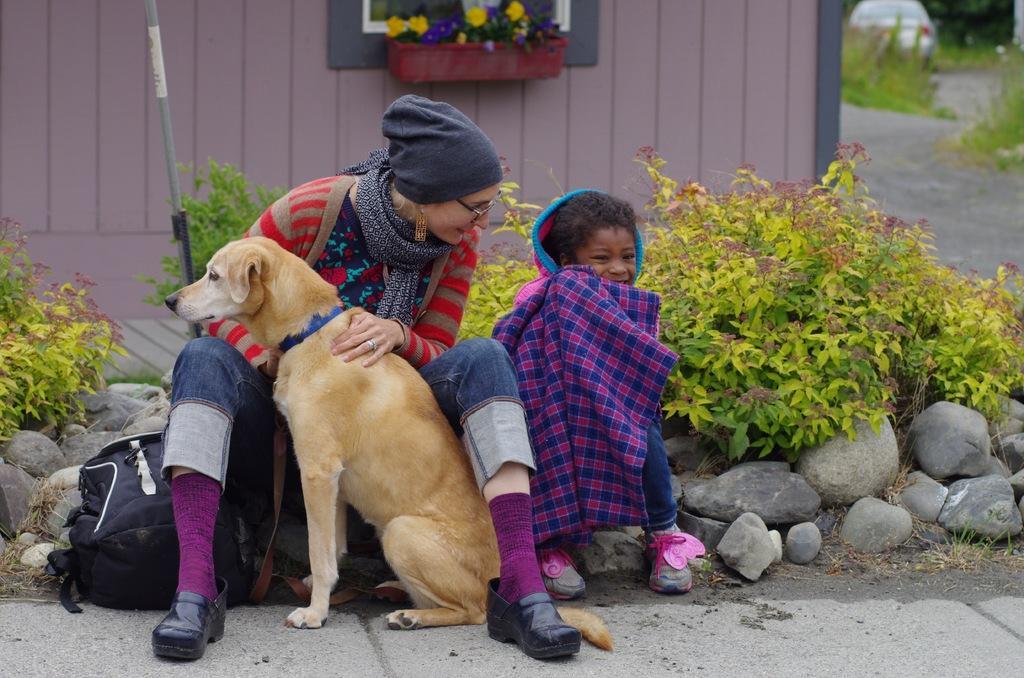Can you describe this image briefly? In this picture there is a woman and a child sitting on the rocks and there is a dog sitting in front of the woman. Beside the woman there is a bag. There are some plants. In the background, there is a flower pot and a wooden wall here. 